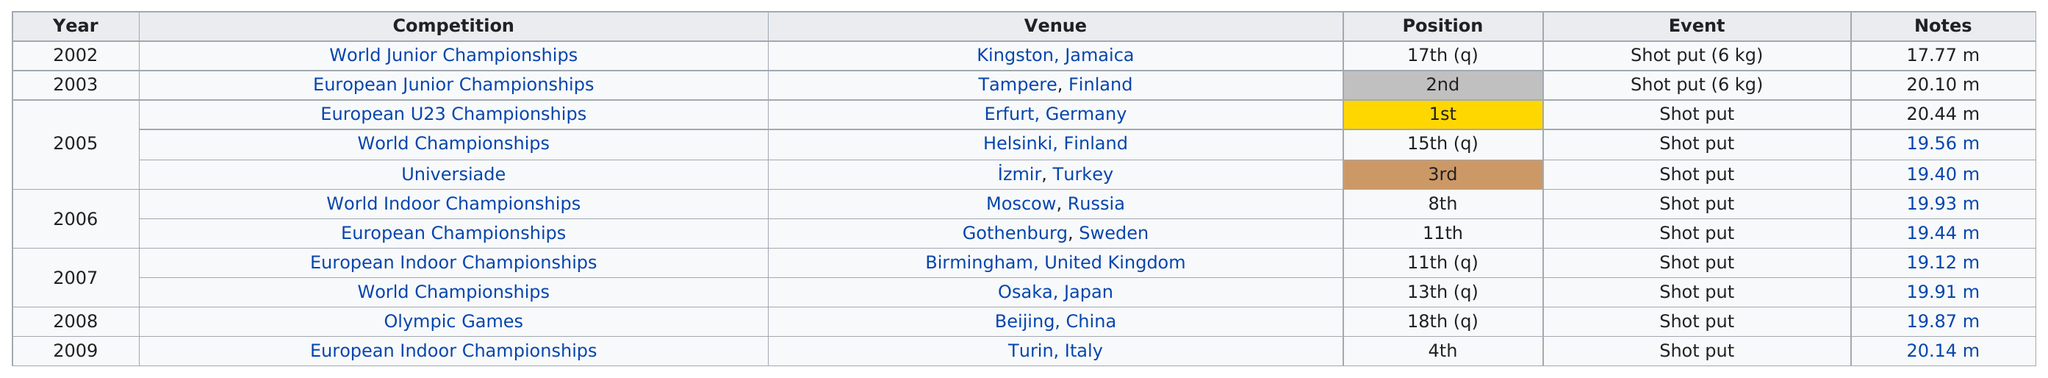Point out several critical features in this image. His top performance was against strong competition at the European U23 Championships, where he proved his dominance and excellence in the sport. He placed first and second a total of 2 times combined. Anton Lyuboslavskiy has been in 11 competitions. Anton Lyuboslavskiy's father's longest show in a competition was 20.44 meters. There are a total of 11 events listed on the chart. 